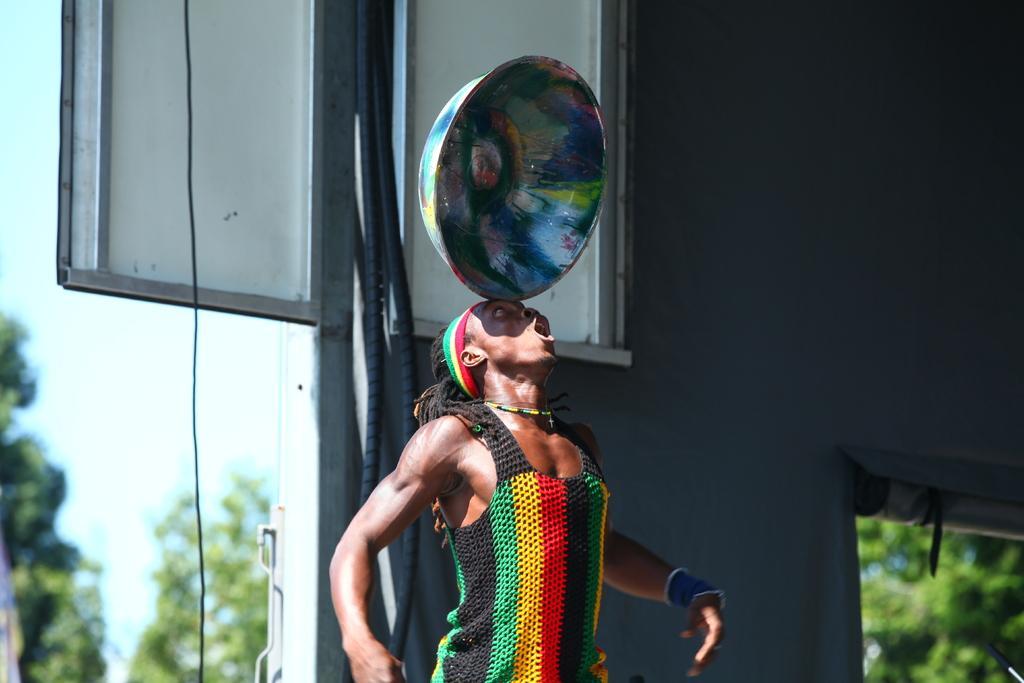Could you give a brief overview of what you see in this image? In this image I can see the person wearing the colorful dress. I can see the bowl on the person's head. In the background I can see the board, wall , many trees and the sky. 